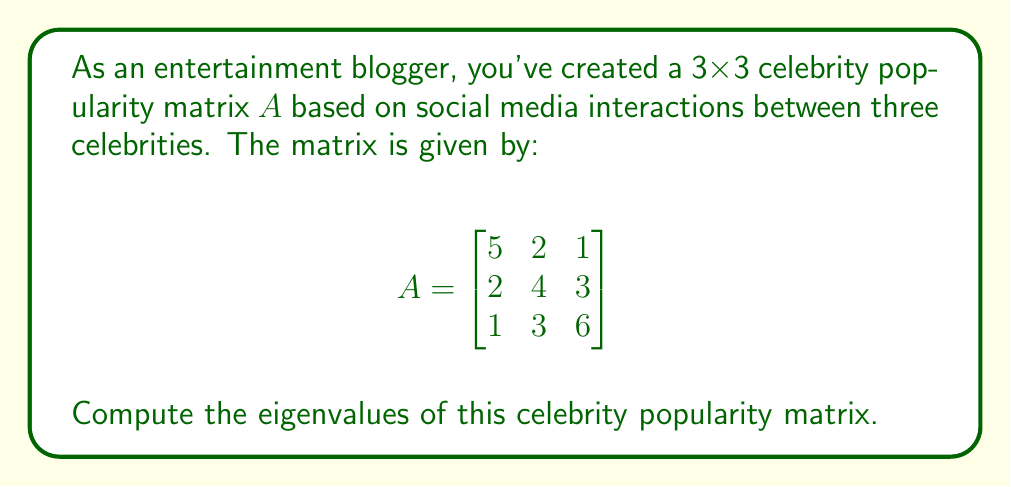Teach me how to tackle this problem. To find the eigenvalues of matrix $A$, we need to solve the characteristic equation:

1) First, we set up the equation $\det(A - \lambda I) = 0$, where $I$ is the 3x3 identity matrix:

   $$\det\begin{pmatrix}
   5-\lambda & 2 & 1 \\
   2 & 4-\lambda & 3 \\
   1 & 3 & 6-\lambda
   \end{pmatrix} = 0$$

2) Expand the determinant:
   $$(5-\lambda)[(4-\lambda)(6-\lambda)-9] - 2[2(6-\lambda)-3] + 1[2\cdot3-(4-\lambda)] = 0$$

3) Simplify:
   $$(5-\lambda)[(24-10\lambda+\lambda^2)-9] - 2[12-2\lambda-3] + [6-(4-\lambda)] = 0$$
   $$(5-\lambda)(15-10\lambda+\lambda^2) - 2(9-2\lambda) + (2+\lambda) = 0$$

4) Expand further:
   $$75-50\lambda+5\lambda^2-15\lambda+10\lambda^2-\lambda^3 - 18+4\lambda + 2+\lambda = 0$$

5) Collect terms:
   $$-\lambda^3 + 15\lambda^2 - 61\lambda + 59 = 0$$

6) This is a cubic equation. It can be solved using various methods, such as the rational root theorem or numerical methods. The roots of this equation are the eigenvalues.

Using a computer algebra system or numerical methods, we find the roots are approximately:

   $\lambda_1 \approx 9.4721$
   $\lambda_2 \approx 3.7639$
   $\lambda_3 \approx 1.7640$

These are the eigenvalues of the celebrity popularity matrix.
Answer: $\lambda_1 \approx 9.4721$, $\lambda_2 \approx 3.7639$, $\lambda_3 \approx 1.7640$ 